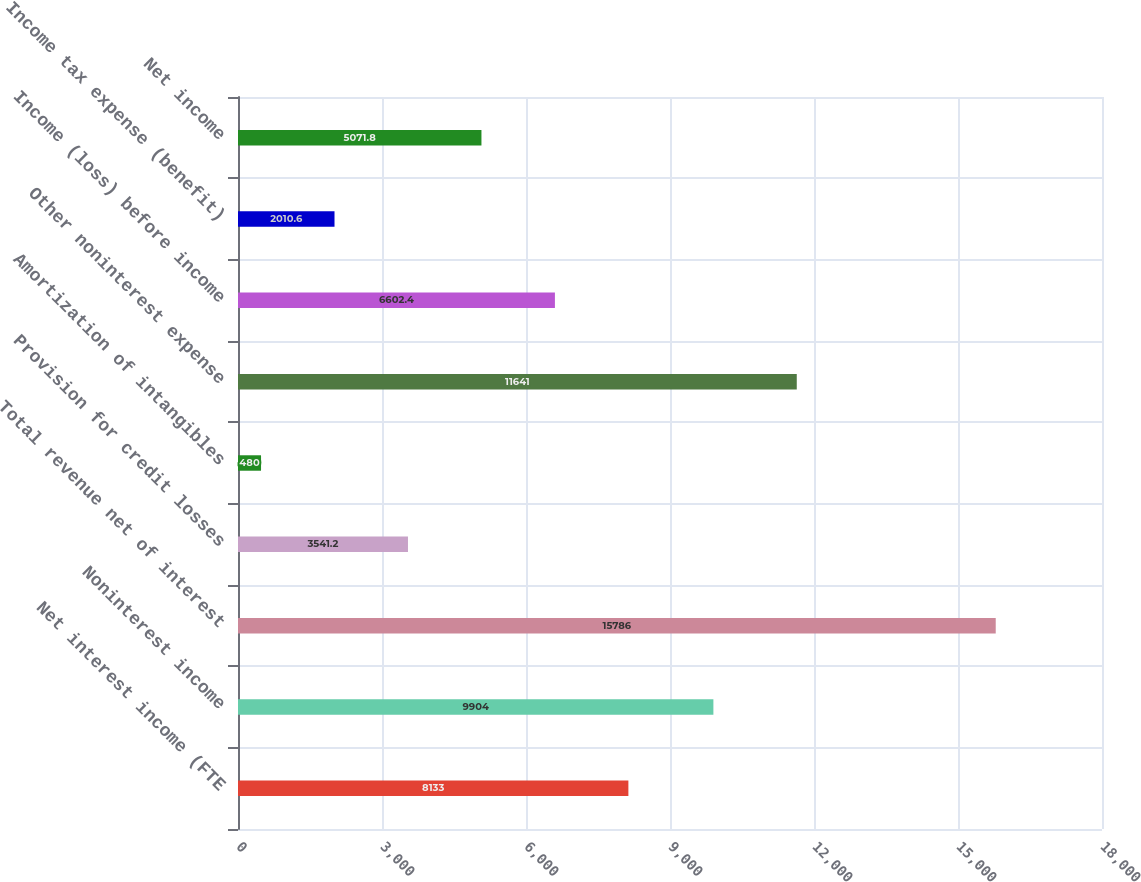Convert chart to OTSL. <chart><loc_0><loc_0><loc_500><loc_500><bar_chart><fcel>Net interest income (FTE<fcel>Noninterest income<fcel>Total revenue net of interest<fcel>Provision for credit losses<fcel>Amortization of intangibles<fcel>Other noninterest expense<fcel>Income (loss) before income<fcel>Income tax expense (benefit)<fcel>Net income<nl><fcel>8133<fcel>9904<fcel>15786<fcel>3541.2<fcel>480<fcel>11641<fcel>6602.4<fcel>2010.6<fcel>5071.8<nl></chart> 